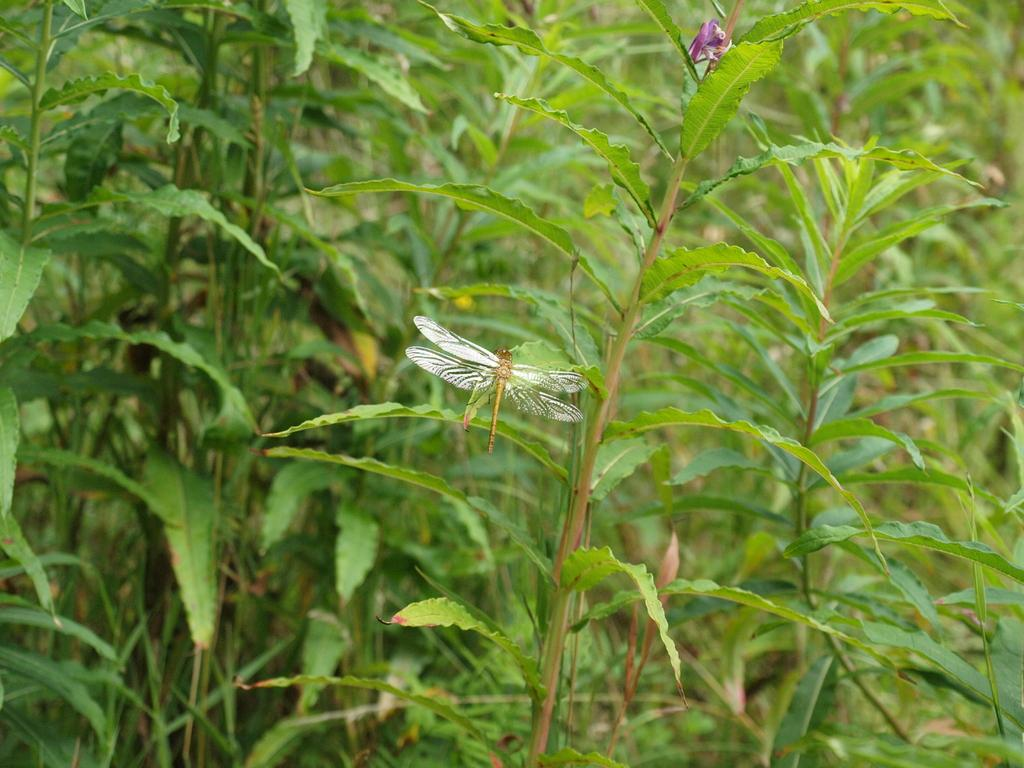What insect can be seen in the image? There is a dragonfly on a leaf in the image. What type of vegetation is present in the image? There are plants in the area of the image. Can you describe the small flower in the image? There is a small flower at the top side of the image. What type of agreement was reached between the clover and the cannon in the image? There is no clover or cannon present in the image, so no such agreement can be observed. 